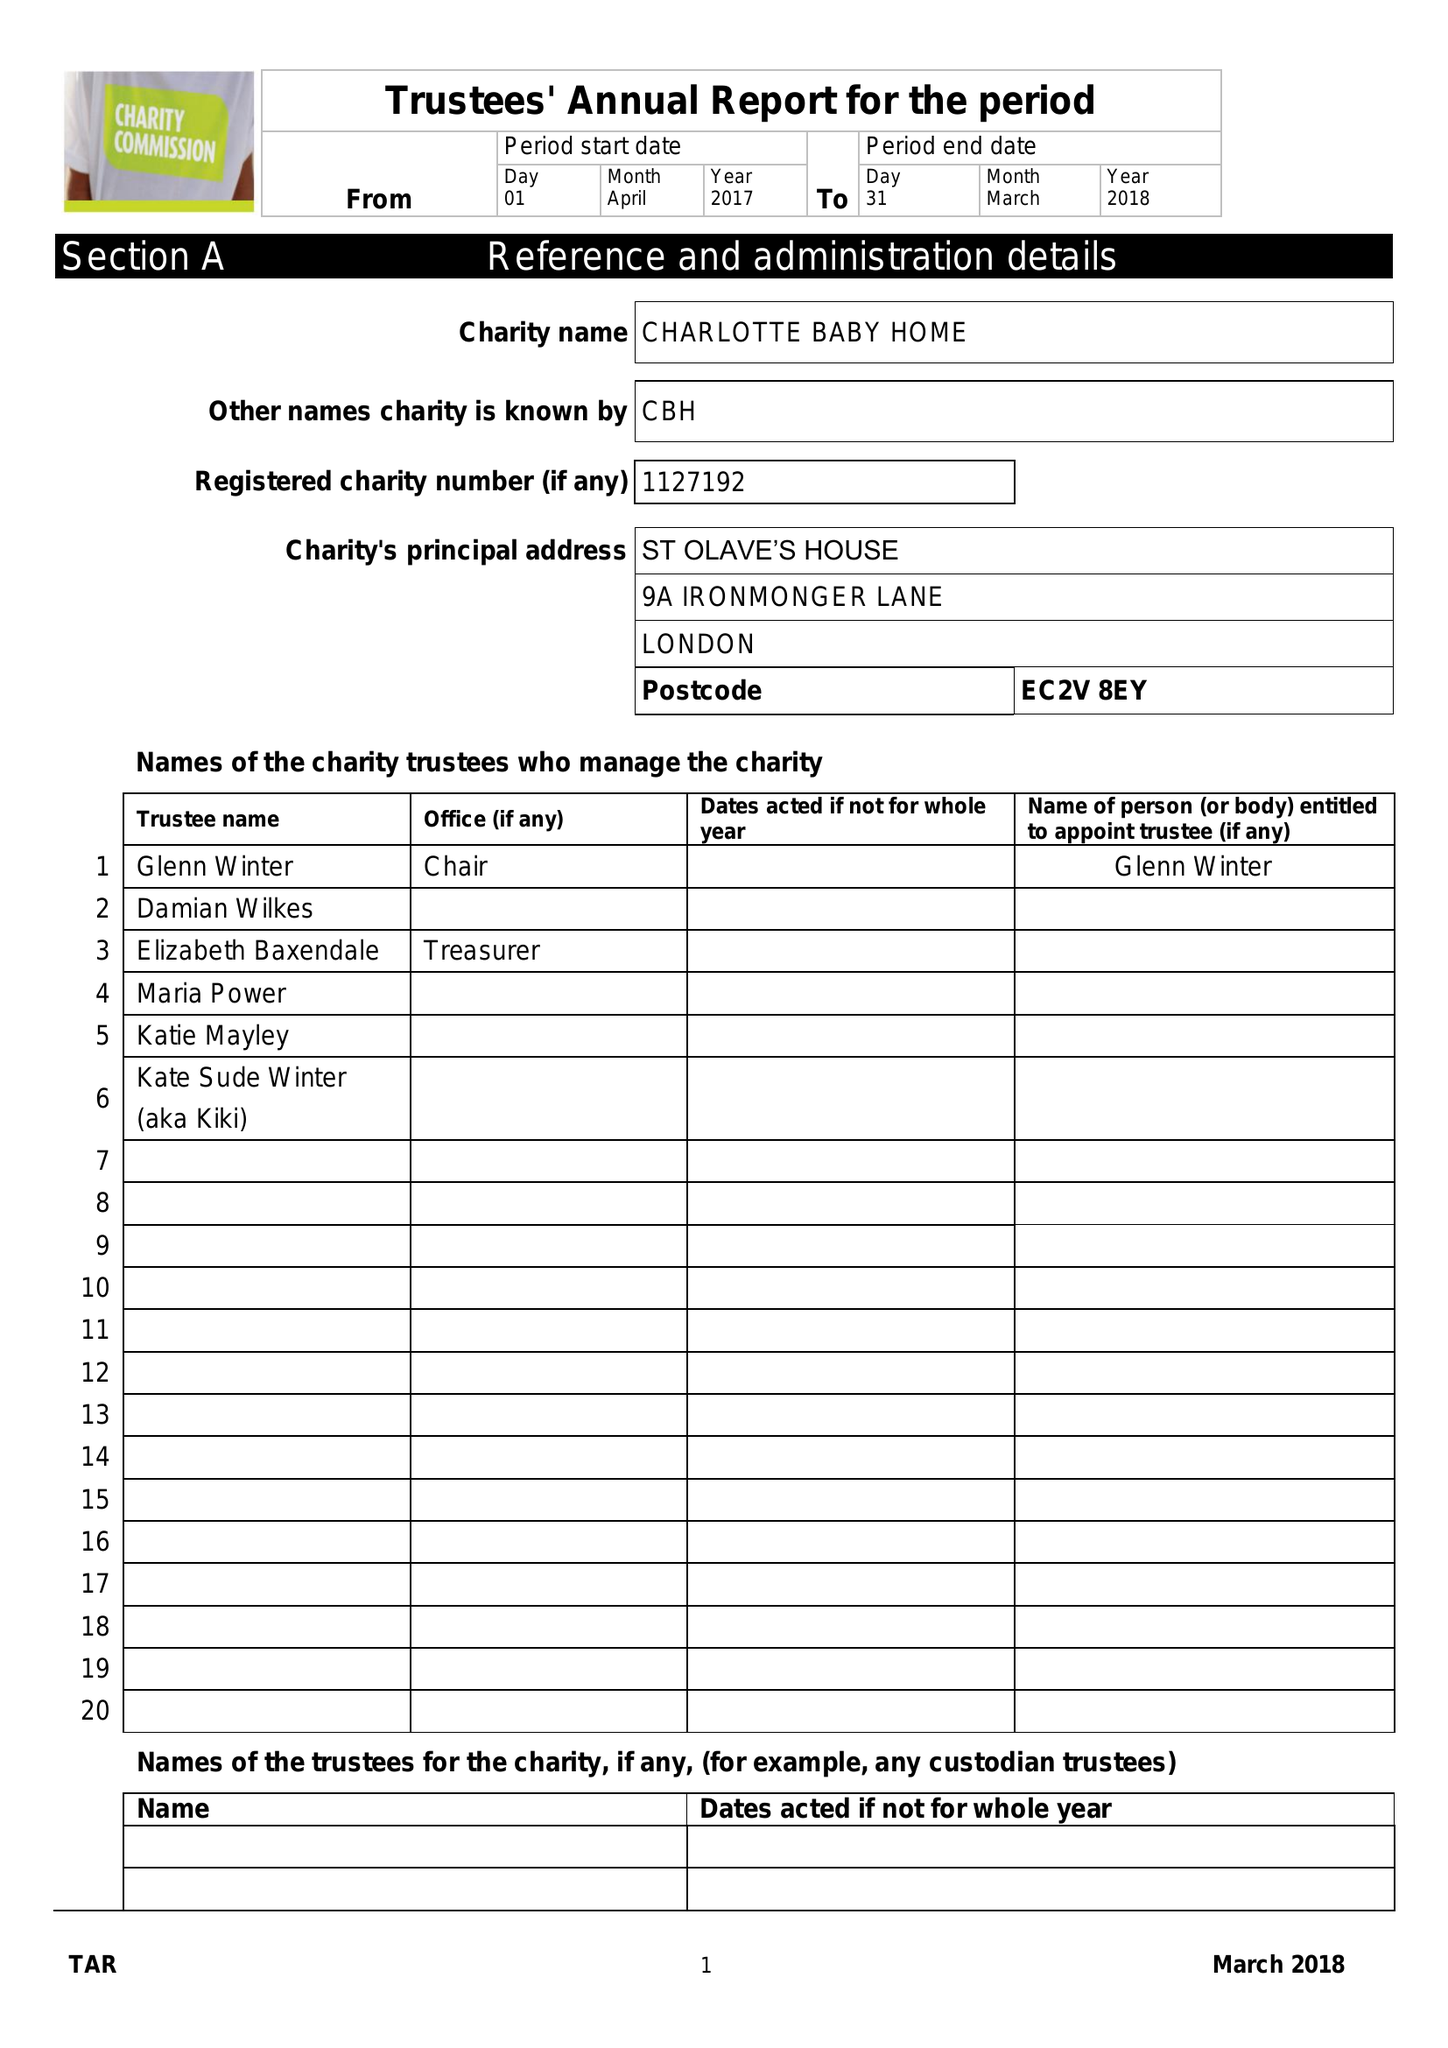What is the value for the address__postcode?
Answer the question using a single word or phrase. EC2V 8EY 